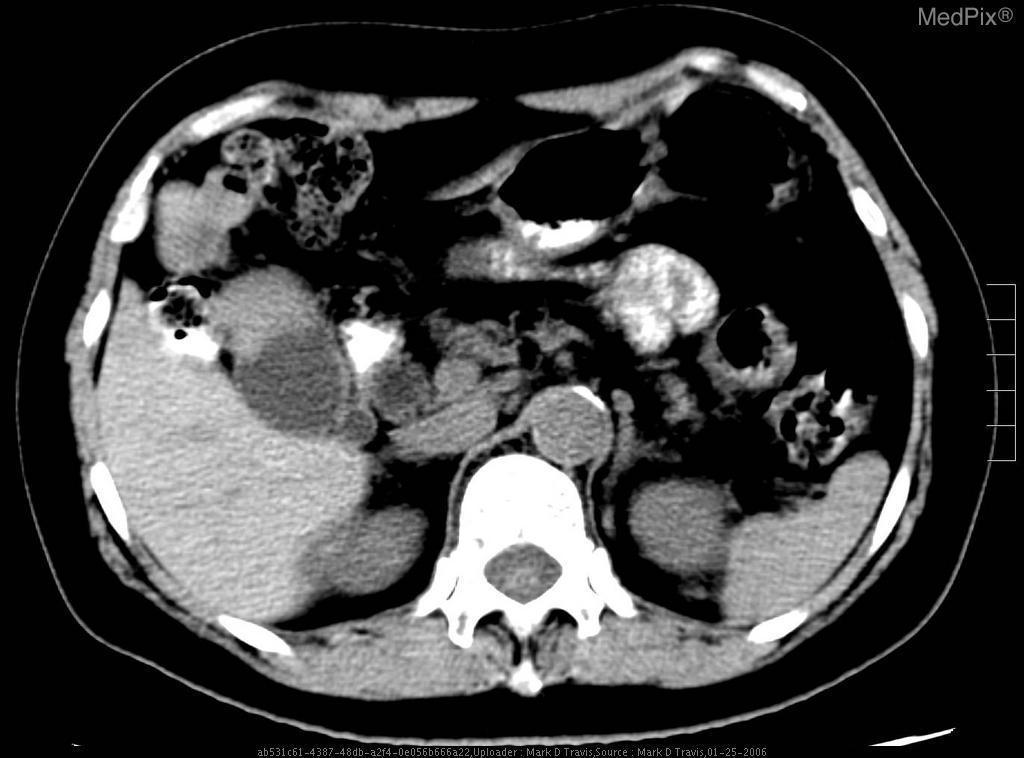Are the cystic and common bile ducts dilated?
Answer briefly. Yes. What symptoms would this patient present with?
Quick response, please. Ruq pain, jaundice,weight loss?. What did the patient likely complain of?
Answer briefly. Abdominal pain. How can you tell if it�s the common bile duct vs the cystic duct?
Give a very brief answer. Trace the gallbladder emptying?. What differentiates the common bile duct and cystic duct?
Quick response, please. Cystic duct is more tortuous. What are common causes of cystic and cbd obstruction?
Quick response, please. Tumors, gallstones. What can cause these findings on imaging?
Answer briefly. Stones, cancer, infection, anatomic variants. How do you tell which side is r vs l?
Be succinct. Imagine the patient is laying down and you are looking from the feet. Is this normal gallbladder finding?
Quick response, please. No. Do you always recommend using both iv and oral contrast?
Quick response, please. No. 